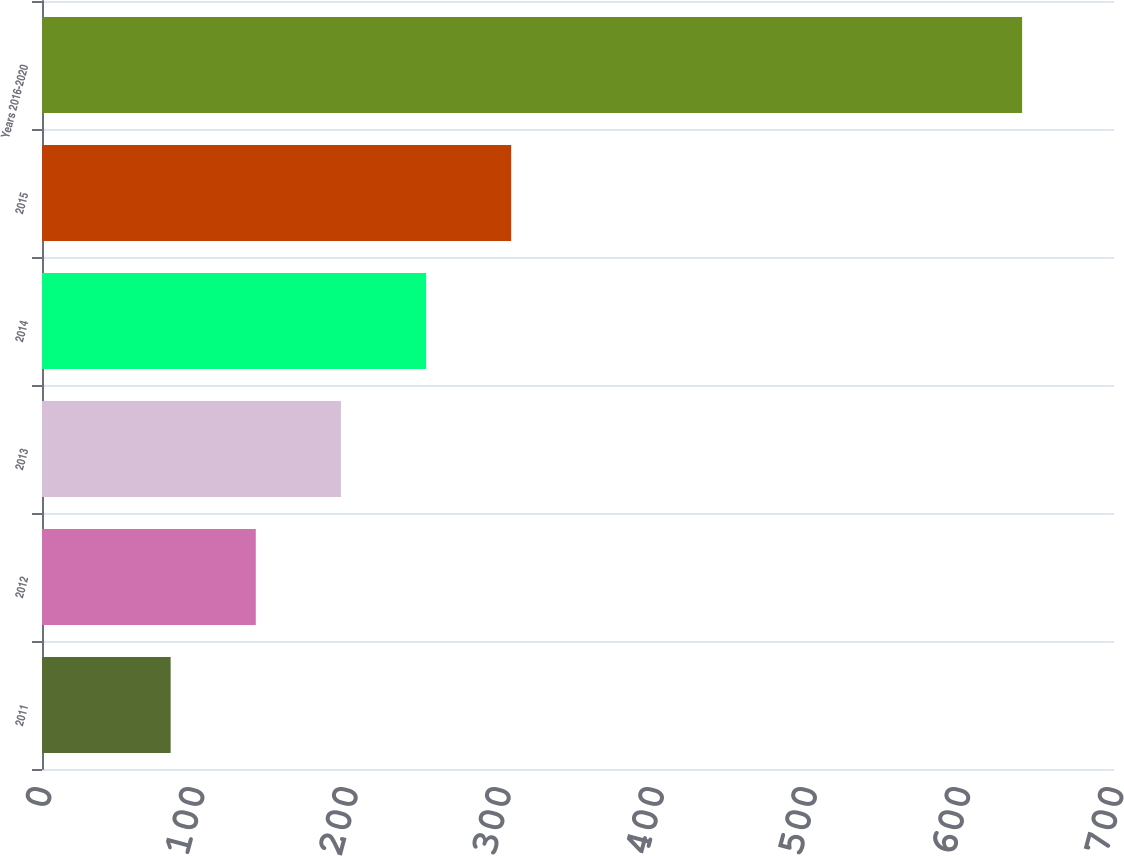Convert chart. <chart><loc_0><loc_0><loc_500><loc_500><bar_chart><fcel>2011<fcel>2012<fcel>2013<fcel>2014<fcel>2015<fcel>Years 2016-2020<nl><fcel>84<fcel>139.6<fcel>195.2<fcel>250.8<fcel>306.4<fcel>640<nl></chart> 